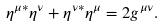Convert formula to latex. <formula><loc_0><loc_0><loc_500><loc_500>\eta ^ { \mu * } \eta ^ { \nu } + \eta ^ { \nu * } \eta ^ { \mu } = 2 g ^ { \mu \nu } .</formula> 